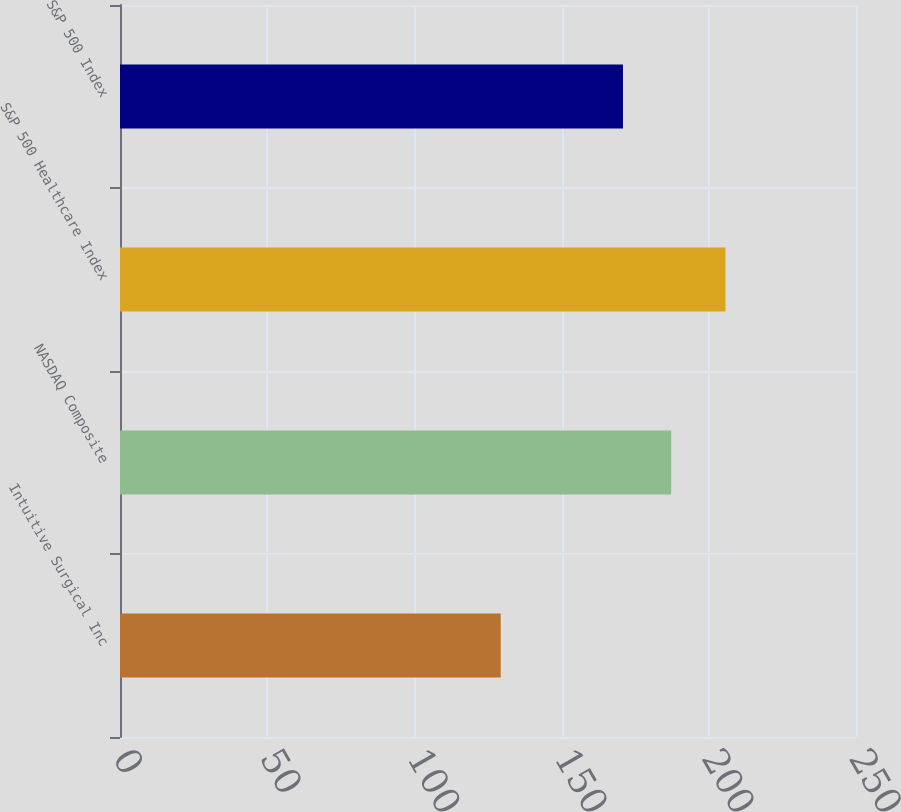Convert chart to OTSL. <chart><loc_0><loc_0><loc_500><loc_500><bar_chart><fcel>Intuitive Surgical Inc<fcel>NASDAQ Composite<fcel>S&P 500 Healthcare Index<fcel>S&P 500 Index<nl><fcel>129.32<fcel>187.22<fcel>205.65<fcel>170.84<nl></chart> 